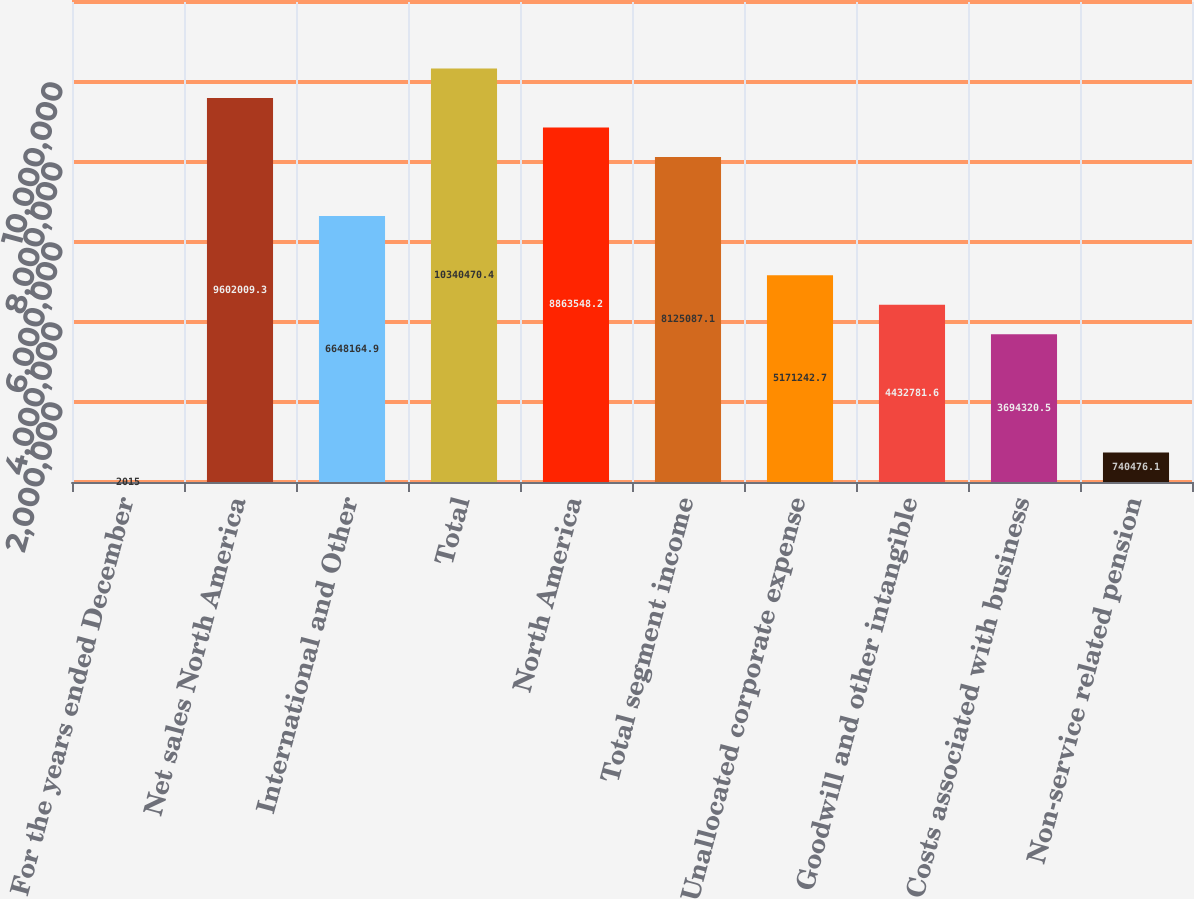<chart> <loc_0><loc_0><loc_500><loc_500><bar_chart><fcel>For the years ended December<fcel>Net sales North America<fcel>International and Other<fcel>Total<fcel>North America<fcel>Total segment income<fcel>Unallocated corporate expense<fcel>Goodwill and other intangible<fcel>Costs associated with business<fcel>Non-service related pension<nl><fcel>2015<fcel>9.60201e+06<fcel>6.64816e+06<fcel>1.03405e+07<fcel>8.86355e+06<fcel>8.12509e+06<fcel>5.17124e+06<fcel>4.43278e+06<fcel>3.69432e+06<fcel>740476<nl></chart> 